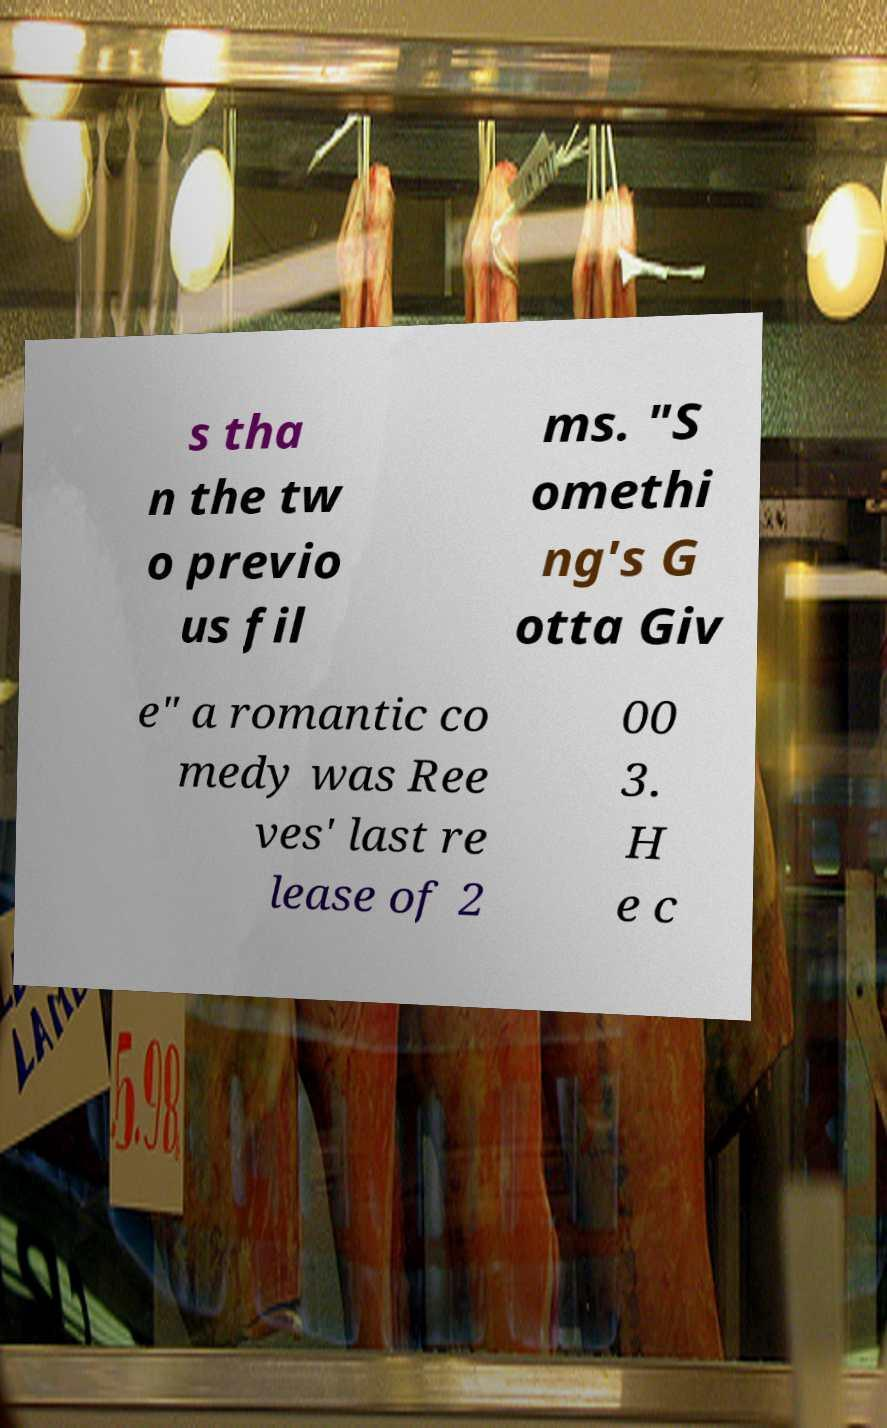I need the written content from this picture converted into text. Can you do that? s tha n the tw o previo us fil ms. "S omethi ng's G otta Giv e" a romantic co medy was Ree ves' last re lease of 2 00 3. H e c 